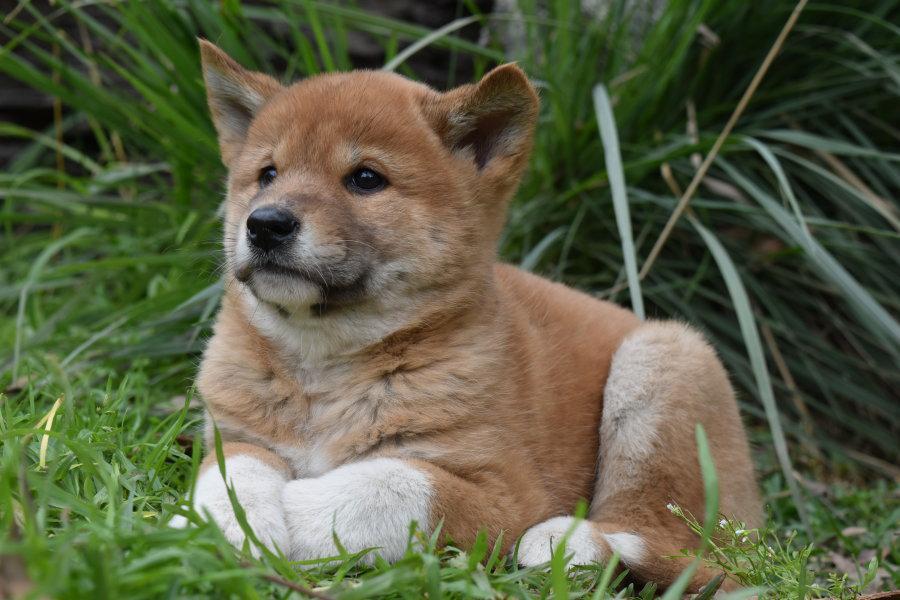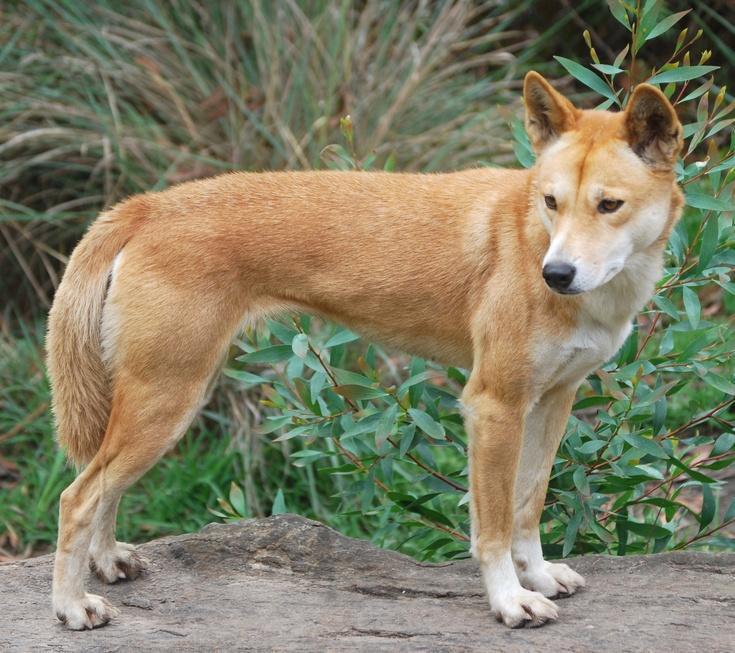The first image is the image on the left, the second image is the image on the right. For the images displayed, is the sentence "The wild dog in the image on the left is lying on the ground." factually correct? Answer yes or no. Yes. 